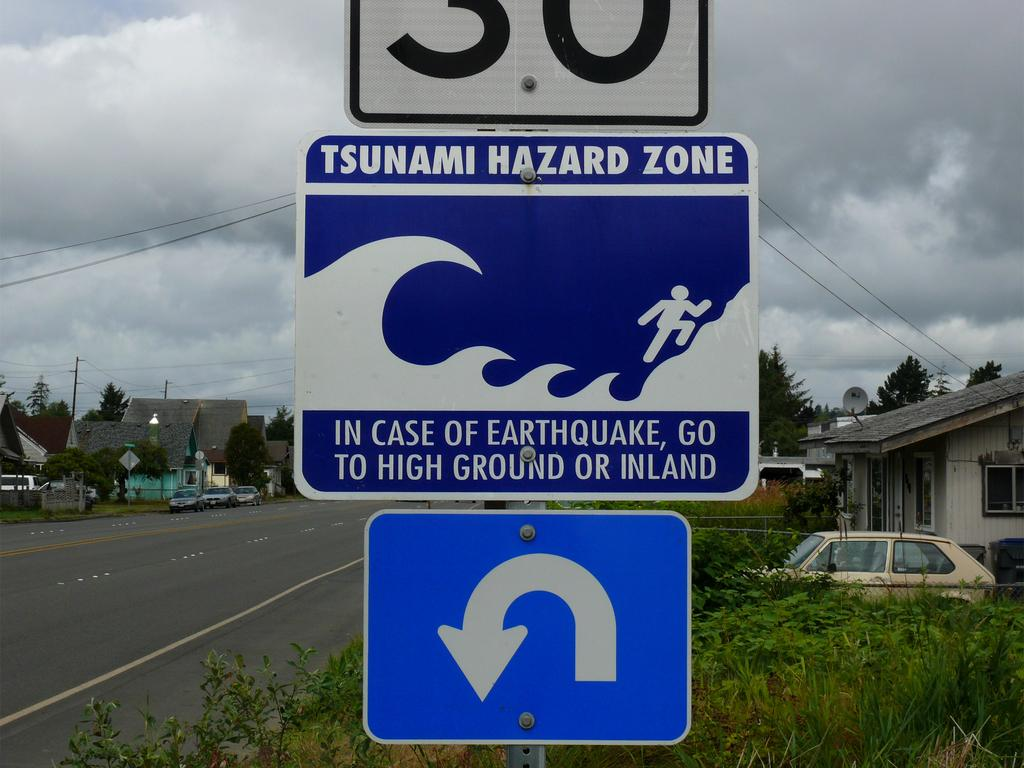Provide a one-sentence caption for the provided image. A tsunami warning sign is shown telling people to seek higher ground or go inland after an earthquake to avoid a large ocean wave. 